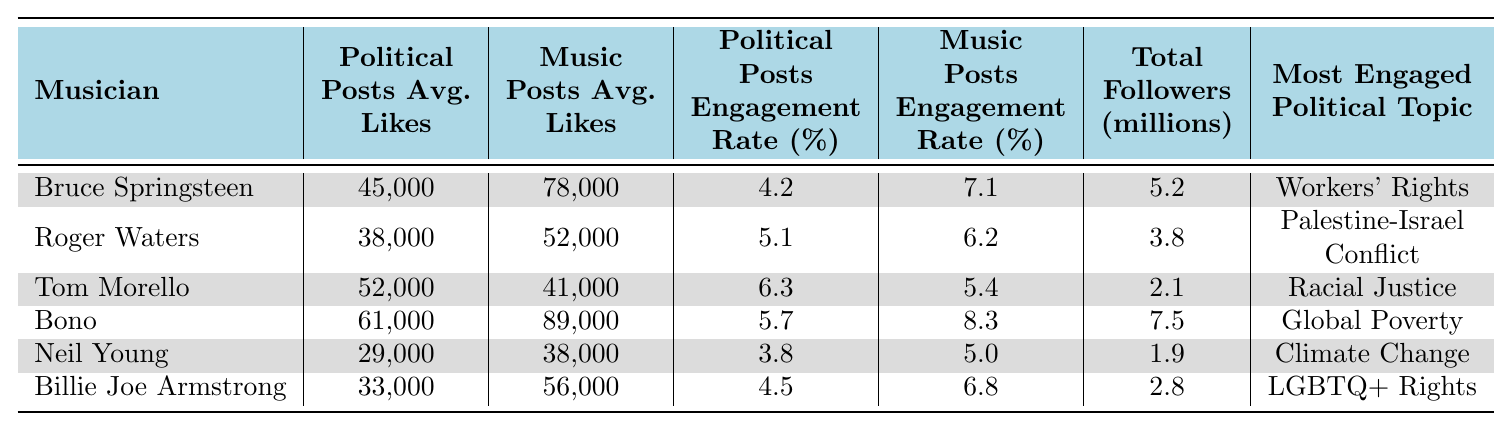What is the average number of likes on political posts for Bruce Springsteen? The data shows that Bruce Springsteen's political posts average 45,000 likes.
Answer: 45,000 Which musician has the highest average engagement rate for music posts? Bono has the highest engagement rate for music posts at 8.3%.
Answer: Bono How many total followers does Neil Young have in millions? Neil Young has 1.9 million total followers according to the table.
Answer: 1.9 What is the difference in average likes between music posts and political posts for Tom Morello? Tom Morello's music posts average 41,000 likes and political posts average 52,000 likes, so the difference is 52,000 - 41,000 = 11,000.
Answer: 11,000 Is it true that Roger Waters has a higher engagement rate on political posts compared to his music posts? Roger Waters has a political posts engagement rate of 5.1% and a music posts engagement rate of 6.2%, which means the statement is false.
Answer: No Which musician's most engaged political topic is related to climate change? The table shows that Neil Young's most engaged political topic is Climate Change.
Answer: Neil Young What is the average political posts engagement rate for all musicians listed? The political posts engagement rates are 4.2%, 5.1%, 6.3%, 5.7%, 3.8%, and 4.5%. Adding these gives 30.6% and dividing by 6 gives an average of 30.6/6 = 5.1%.
Answer: 5.1% How many musicians have higher average likes on music posts compared to political posts? Comparing averages, Bruce Springsteen, Bono, and Billie Joe Armstrong have higher likes on music posts than political posts. That's a total of 3 musicians.
Answer: 3 What is the most engaged political topic for Tom Morello? According to the table, the most engaged political topic for Tom Morello is Racial Justice.
Answer: Racial Justice What is the total of political posts' average likes across all musicians? The total is calculated by adding 45,000 + 38,000 + 52,000 + 61,000 + 29,000 + 33,000, which equals 258,000.
Answer: 258,000 